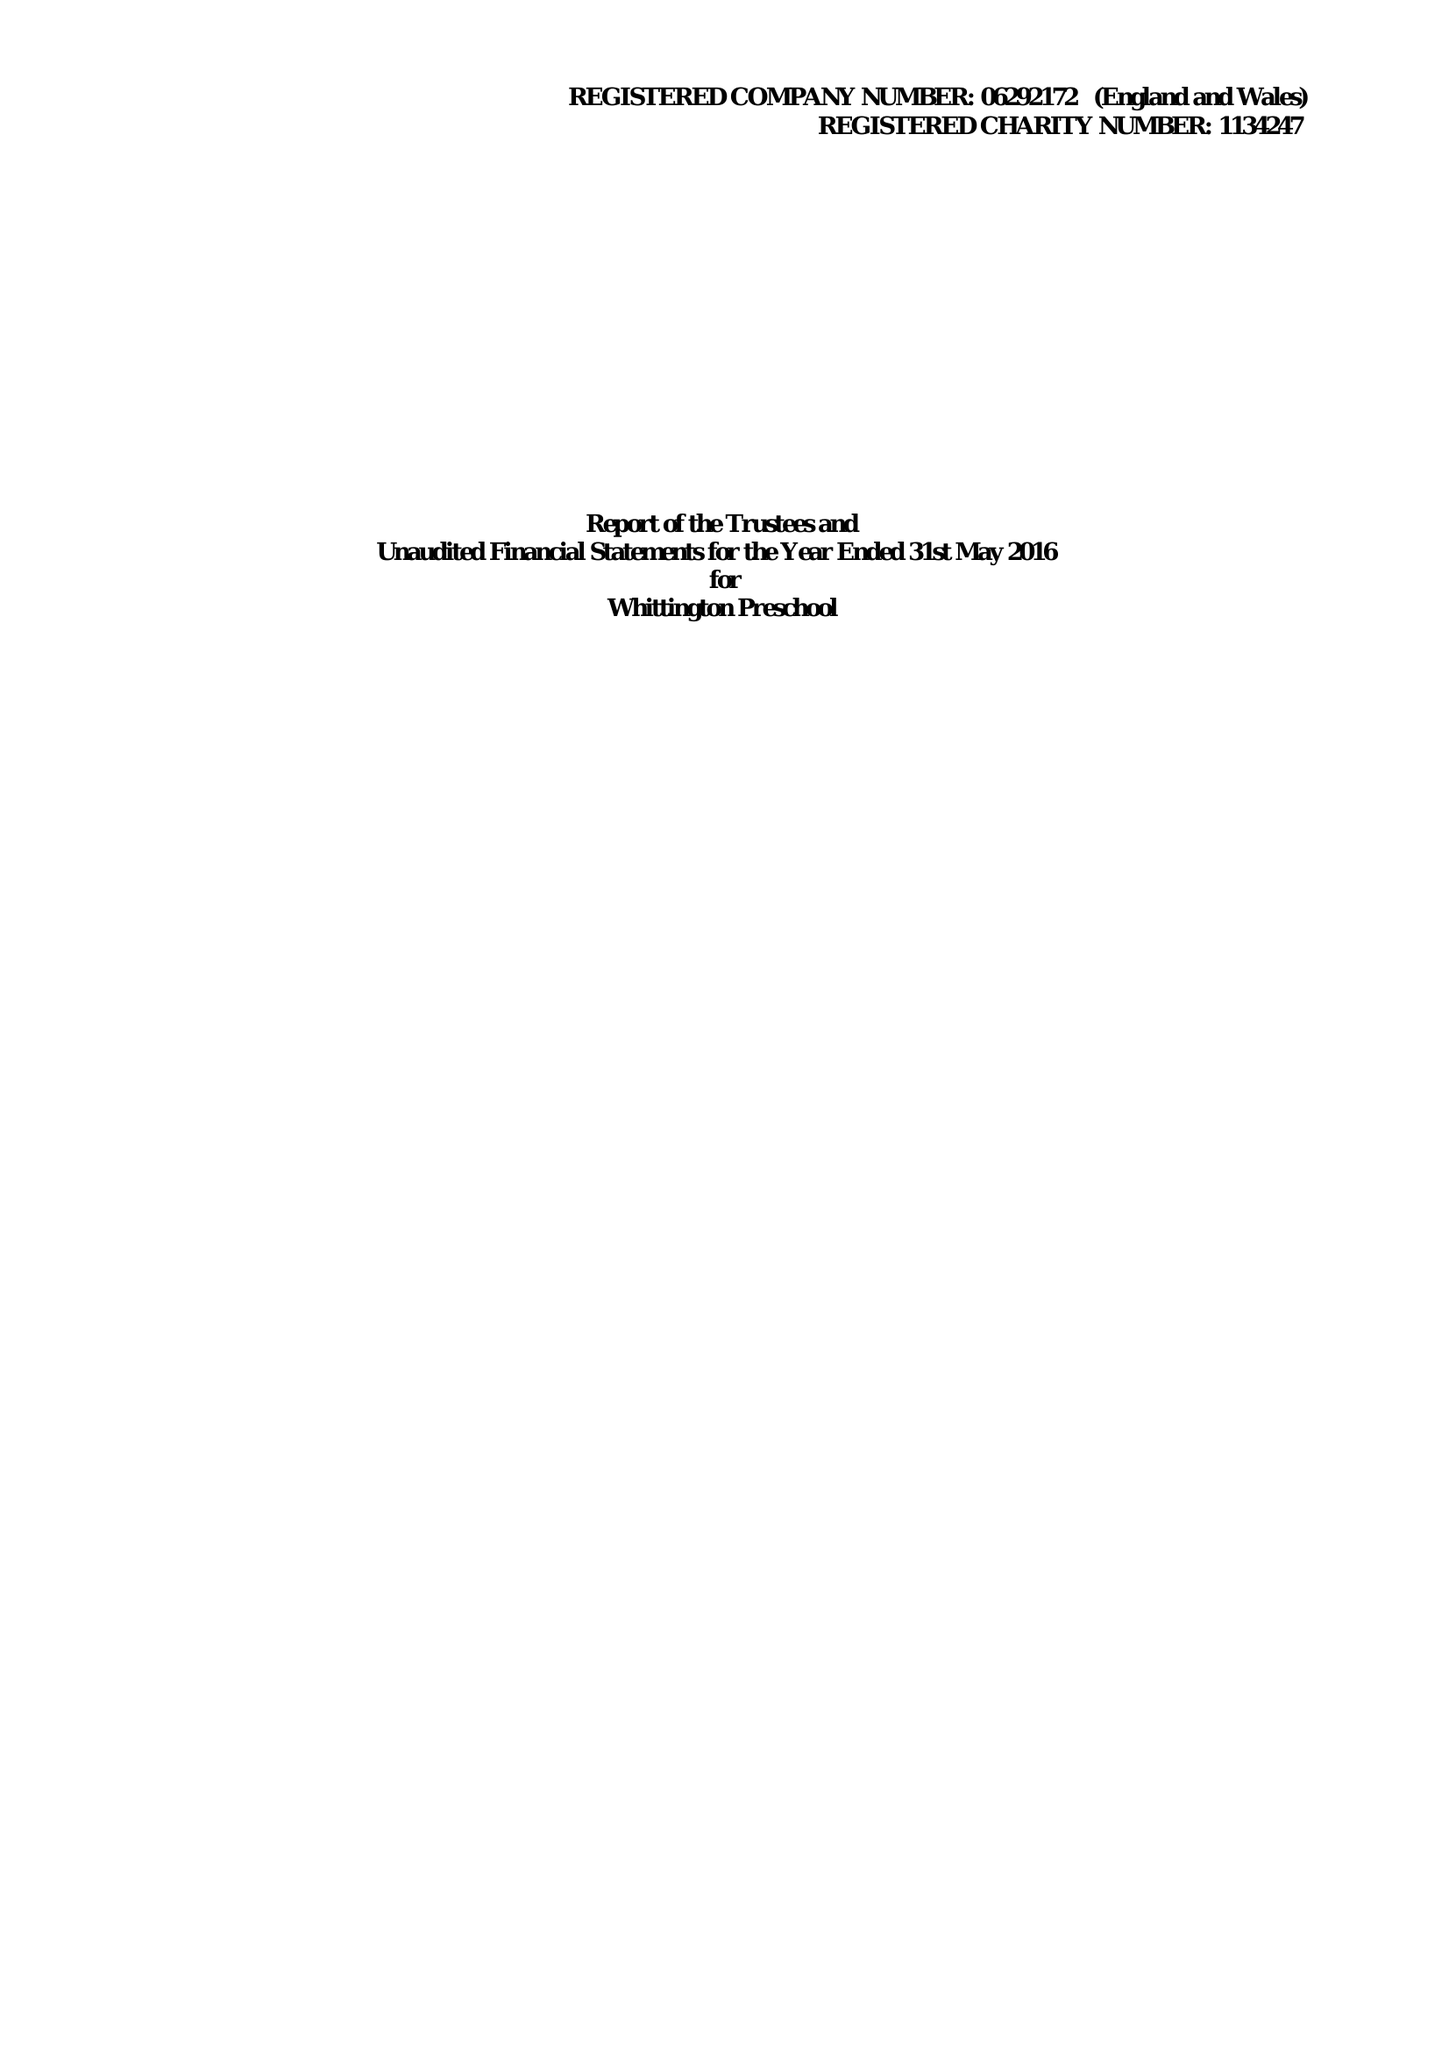What is the value for the income_annually_in_british_pounds?
Answer the question using a single word or phrase. 234870.00 